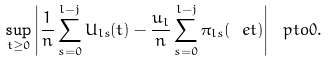Convert formula to latex. <formula><loc_0><loc_0><loc_500><loc_500>\sup _ { t \geq 0 } \left | \frac { 1 } { n } \sum _ { s = 0 } ^ { l - j } U _ { l s } ( t ) - \frac { u _ { l } } n \sum _ { s = 0 } ^ { l - j } \pi _ { l s } ( \ e t ) \right | \ p t o 0 .</formula> 